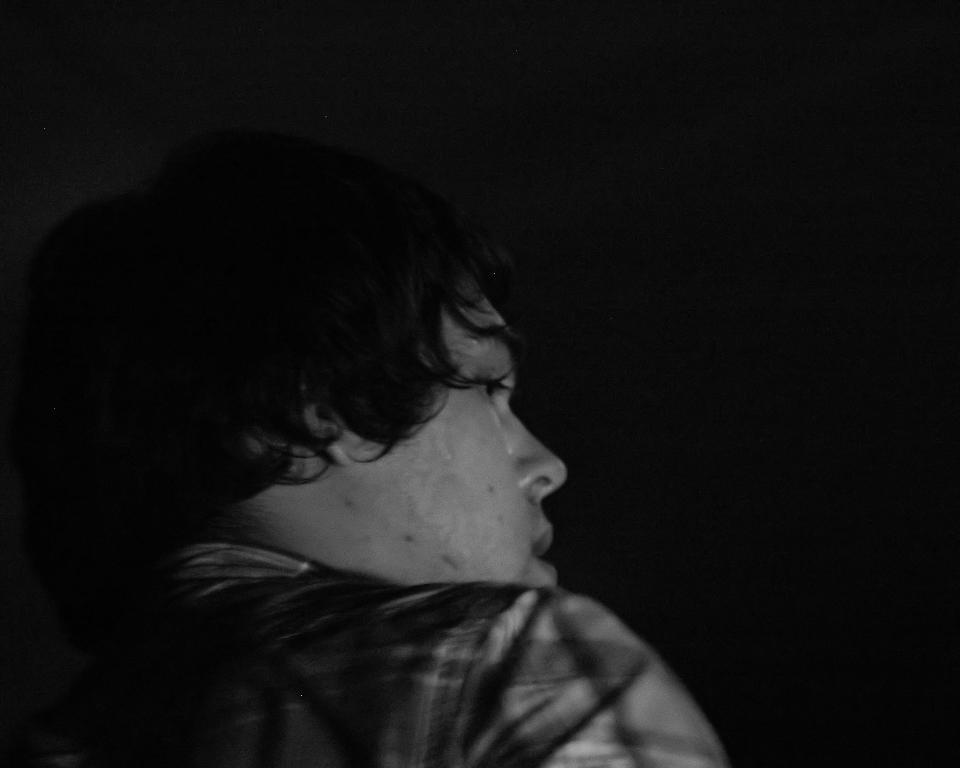Who is present in the image? There is a man in the image. What is the man wearing? The man is wearing a black shirt. Can you describe the lighting in the image? The image is dark. What type of fowl can be seen in the image? There is no fowl present in the image; it features a man wearing a black shirt in a dark setting. What type of tank is visible in the image? There is no tank present in the image. 